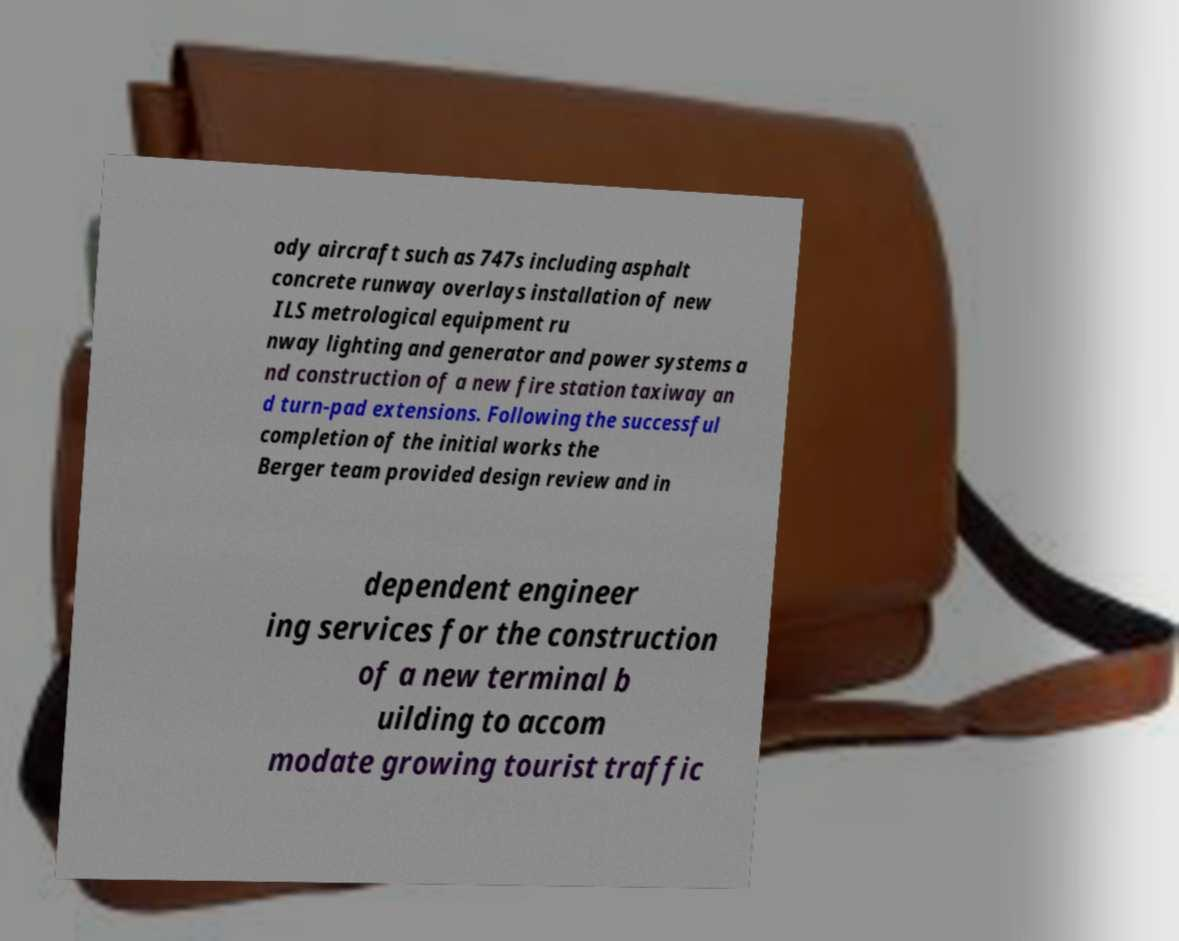What messages or text are displayed in this image? I need them in a readable, typed format. ody aircraft such as 747s including asphalt concrete runway overlays installation of new ILS metrological equipment ru nway lighting and generator and power systems a nd construction of a new fire station taxiway an d turn-pad extensions. Following the successful completion of the initial works the Berger team provided design review and in dependent engineer ing services for the construction of a new terminal b uilding to accom modate growing tourist traffic 